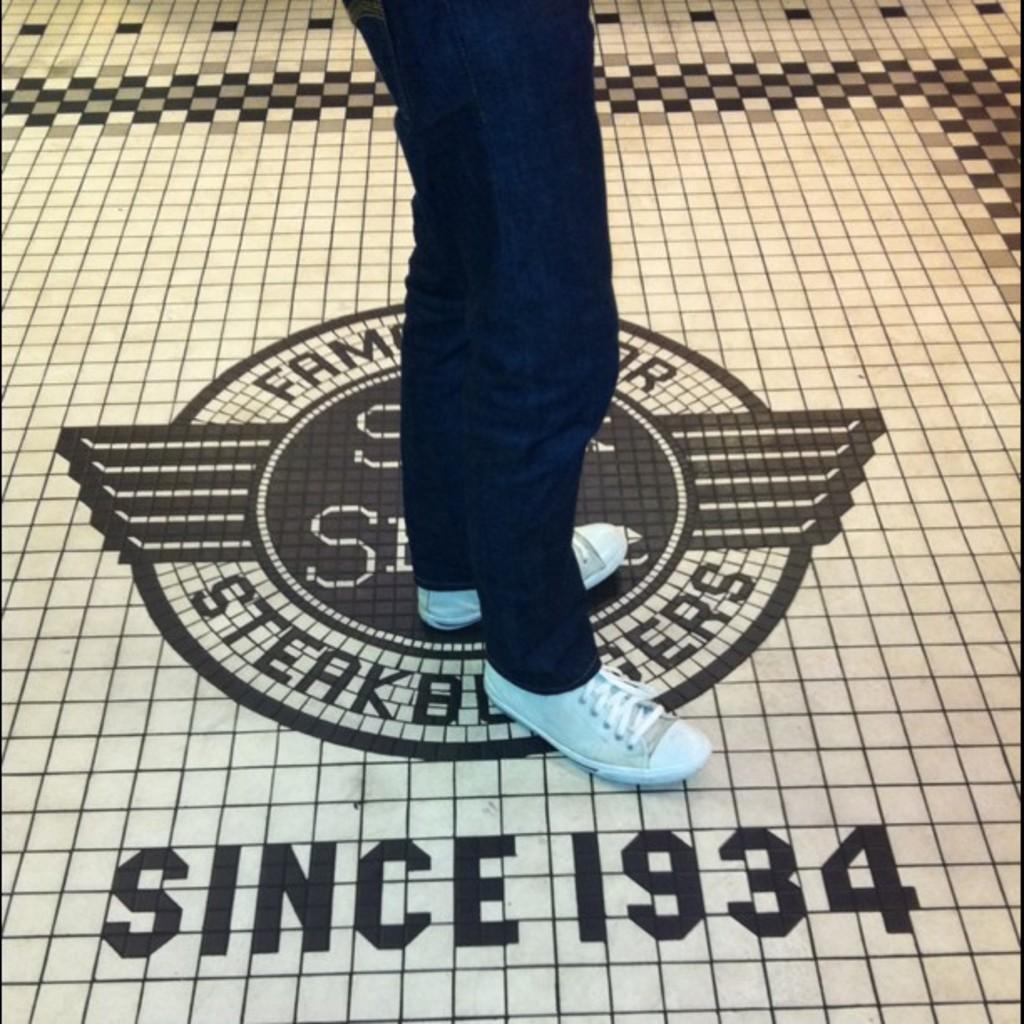In one or two sentences, can you explain what this image depicts? In this image there is a person standing on floor. 